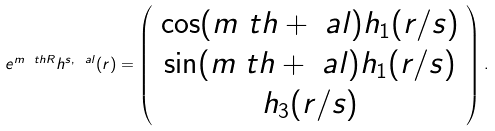<formula> <loc_0><loc_0><loc_500><loc_500>e ^ { m \ t h R } h ^ { s , \ a l } ( r ) = \left ( \begin{array} { c } \cos ( m \ t h + \ a l ) h _ { 1 } ( r / s ) \\ \sin ( m \ t h + \ a l ) h _ { 1 } ( r / s ) \\ h _ { 3 } ( r / s ) \end{array} \right ) .</formula> 